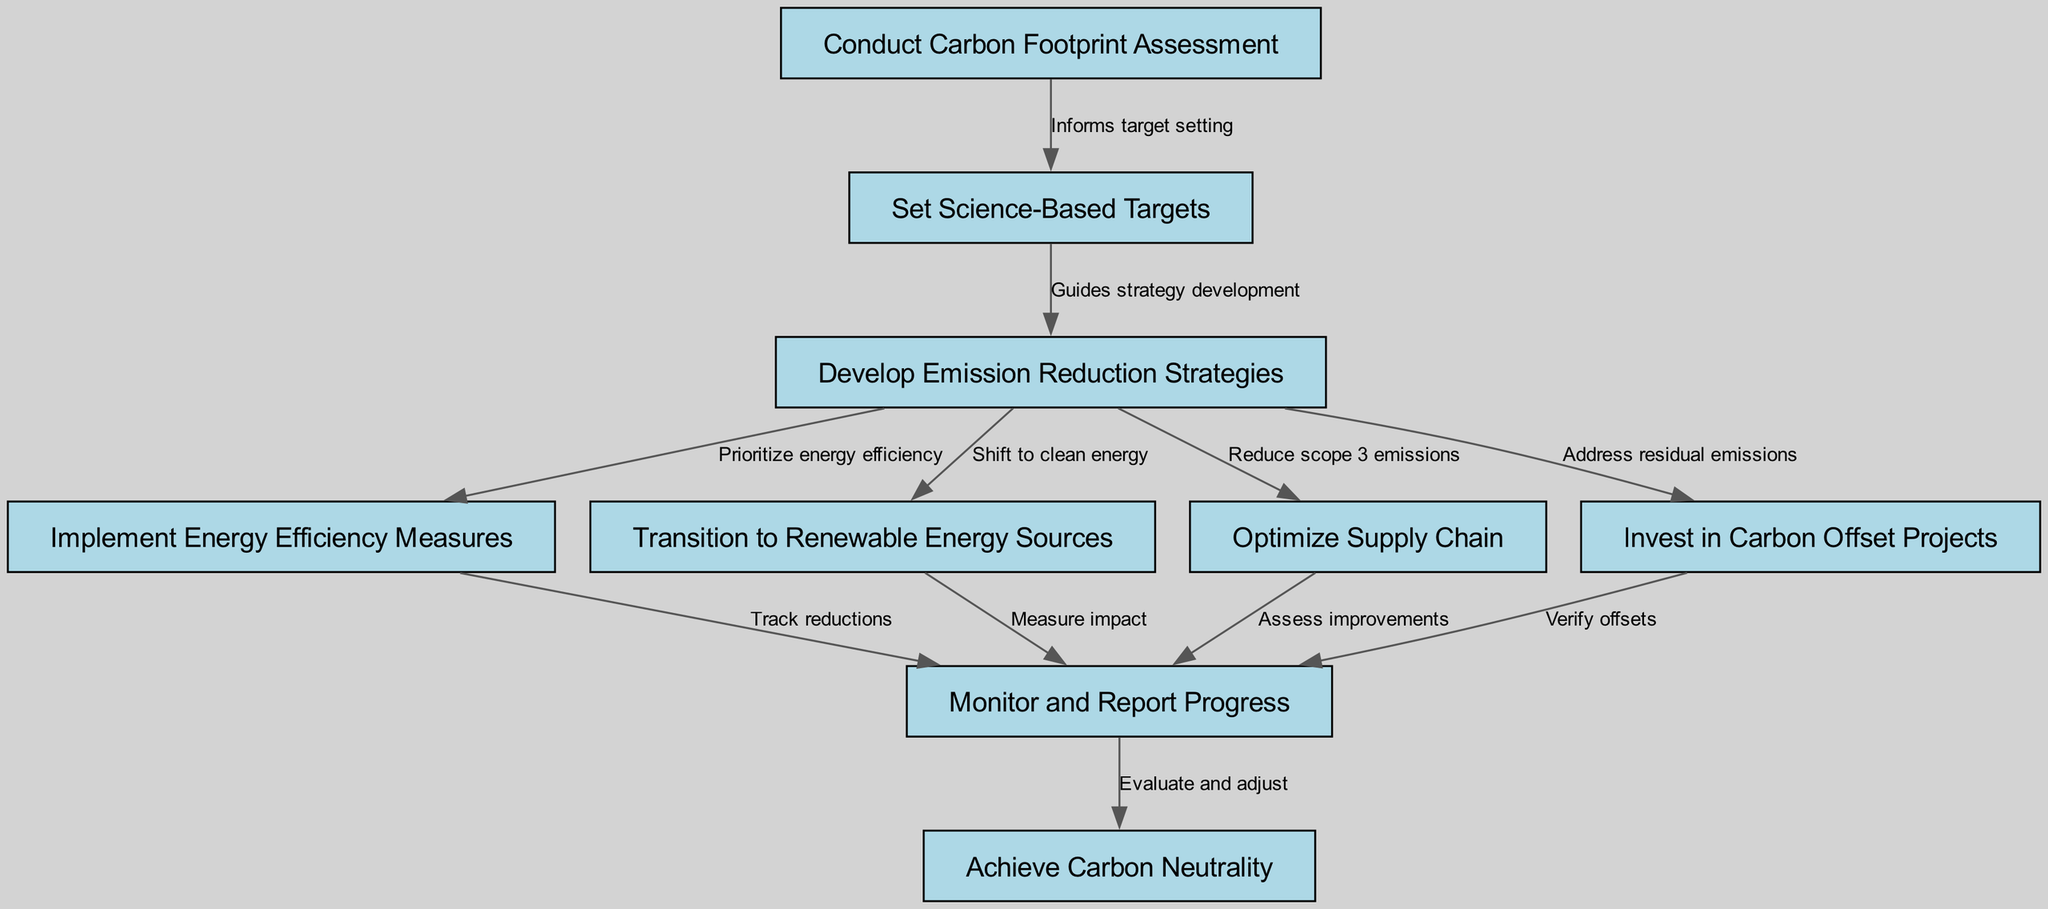What is the first step in the corporate carbon neutrality strategy? The diagram shows that the first step is to "Conduct Carbon Footprint Assessment" as it is the initial node that begins the pathway.
Answer: Conduct Carbon Footprint Assessment How many nodes are present in the diagram? Counting all the nodes listed, there are a total of nine nodes in the diagram representing different steps in the pathway.
Answer: Nine Which node follows after "Set Science-Based Targets"? According to the diagram, the node that follows "Set Science-Based Targets" is "Develop Emission Reduction Strategies" as indicated by the directed edge connecting these two nodes.
Answer: Develop Emission Reduction Strategies What does the edge from "Develop Emission Reduction Strategies" to "Implement Energy Efficiency Measures" represent? The edge signifies that "Develop Emission Reduction Strategies" prioritizes energy efficiency, as noted in the text label describing their relationship.
Answer: Prioritize energy efficiency What step occurs after "Monitor and Report Progress"? The diagram shows that the step that follows "Monitor and Report Progress" is "Achieve Carbon Neutrality," which is the final goal of the pathway.
Answer: Achieve Carbon Neutrality What is the relationship between "Transition to Renewable Energy Sources" and "Monitor and Report Progress"? The relationship is indirect; both nodes lead into "Monitor and Report Progress," suggesting both steps contribute to the monitoring phase but do not directly connect to each other.
Answer: Indirect relationship How many edges connect to the "Monitor and Report Progress" node? There are four edges connecting to "Monitor and Report Progress," indicating that several strategies contribute to monitoring progress on the carbon neutrality journey.
Answer: Four What do the edges from "Develop Emission Reduction Strategies" direct towards? The edges from "Develop Emission Reduction Strategies" direct towards "Implement Energy Efficiency Measures," "Transition to Renewable Energy Sources," "Optimize Supply Chain," and "Invest in Carbon Offset Projects," indicating multiple strategies stemming from one main strategy development.
Answer: Four directions What is the ultimate goal indicated in the pathway? The ultimate goal indicated in the pathway is "Achieve Carbon Neutrality," which is positioned as the final node in the sequence of actions taken.
Answer: Achieve Carbon Neutrality 